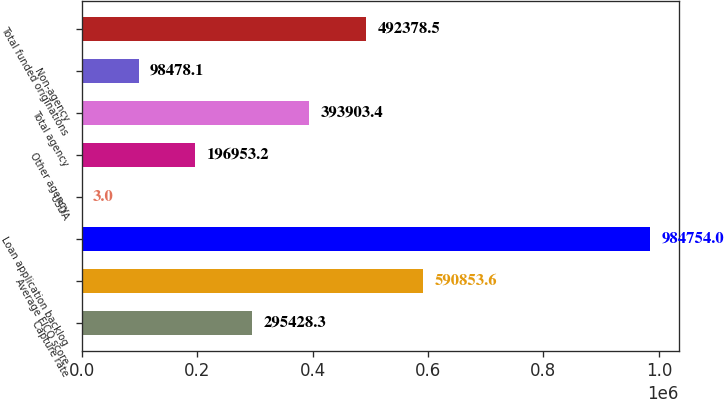Convert chart. <chart><loc_0><loc_0><loc_500><loc_500><bar_chart><fcel>Capture rate<fcel>Average FICO score<fcel>Loan application backlog<fcel>USDA<fcel>Other agency<fcel>Total agency<fcel>Non-agency<fcel>Total funded originations<nl><fcel>295428<fcel>590854<fcel>984754<fcel>3<fcel>196953<fcel>393903<fcel>98478.1<fcel>492378<nl></chart> 